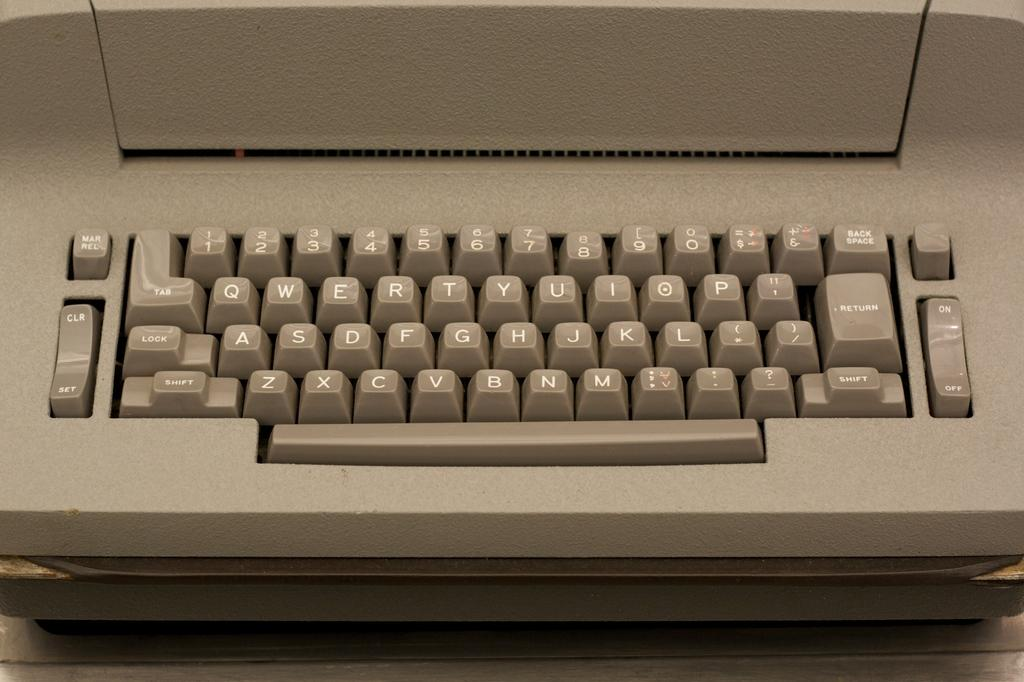What is the main object in the image? There is a computer keyboard in the image. What might someone use the computer keyboard for? The computer keyboard is typically used for typing and inputting commands into a computer. Can you describe the layout of the keyboard? The keyboard has various keys arranged in a specific layout, including letters, numbers, and special function keys. How deep is the water surrounding the computer keyboard in the image? There is no water present in the image; it only features a computer keyboard. 